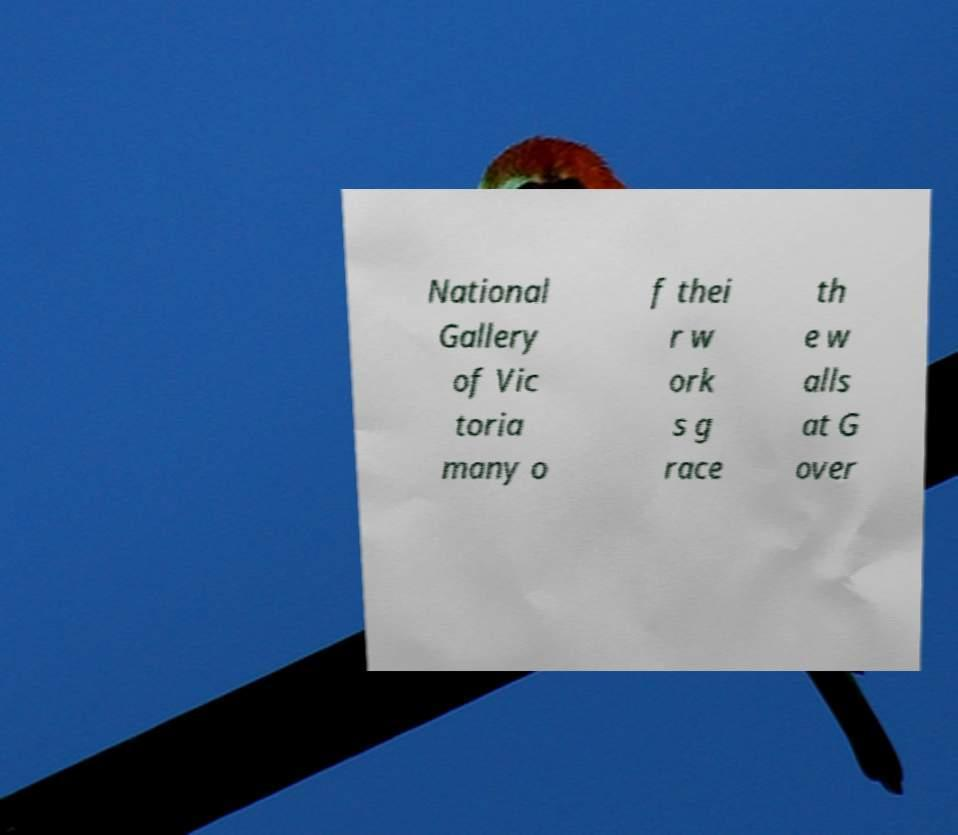What messages or text are displayed in this image? I need them in a readable, typed format. National Gallery of Vic toria many o f thei r w ork s g race th e w alls at G over 